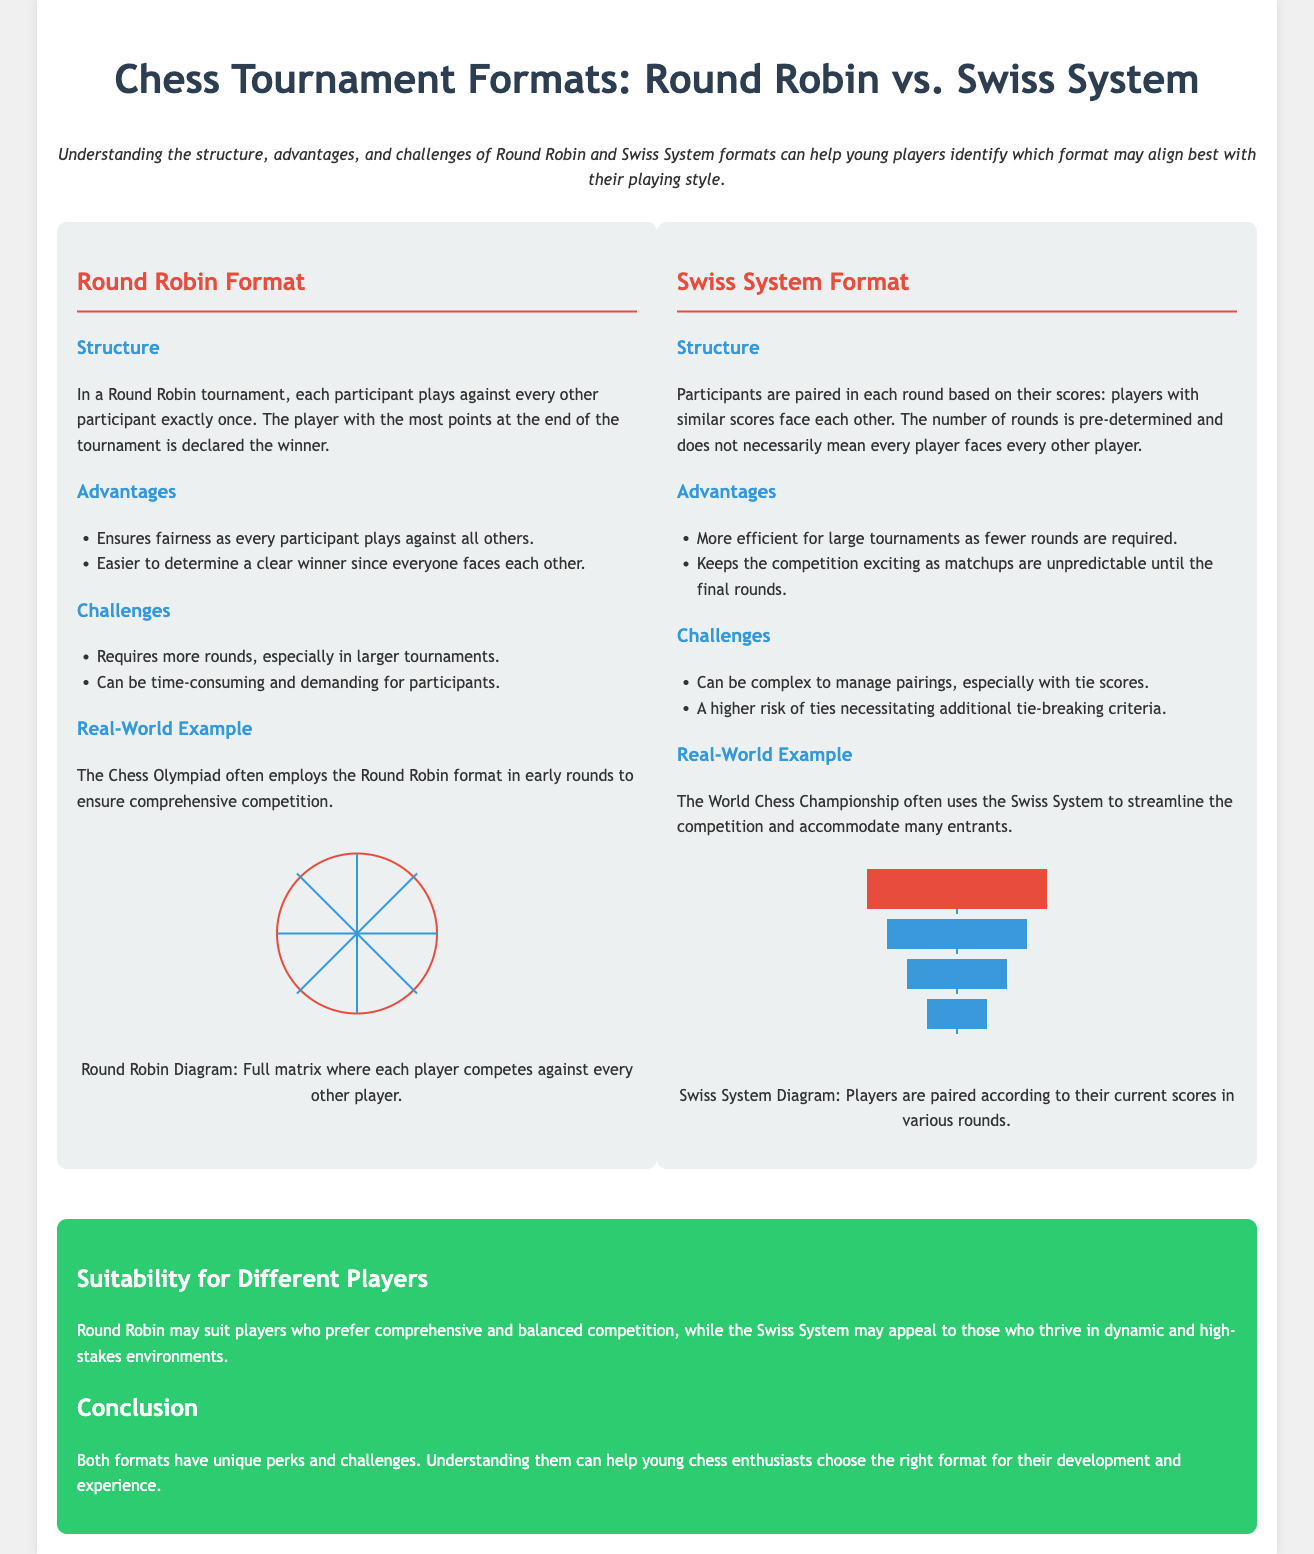What is the title of the document? The title of the document is stated at the top and indicates the focus on chess tournament formats, specifically comparing Round Robin and Swiss System.
Answer: Chess Tournament Formats: Round Robin vs. Swiss System What is one advantage of the Round Robin format? The document lists advantages for the Round Robin format, highlighting fairness as a key benefit.
Answer: Ensures fairness What is a challenge of the Swiss System format? The challenges for the Swiss System format are documented, with complexity in managing pairings being one of them.
Answer: Complex to manage pairings How are players paired in the Swiss System format? The document explains that players are paired based on their scores, emphasizing the difference in pairing methods between formats.
Answer: Based on their scores What is a real-world example of a Round Robin format? The document provides examples of tournaments using the formats, specifying a known chess event for the Round Robin approach.
Answer: The Chess Olympiad Which format might suit players who prefer balanced competition? The conclusion section suggests that players looking for balanced gameplay may find one format more suitable than the other.
Answer: Round Robin What color is used for the headings in the Round Robin section? The document uses specific colors for headings, and the Round Robin section is identified by its distinct heading color.
Answer: Red What does the conclusion indicate about both formats? The conclusion summarizes the uniqueness of each format and their implications for players, giving a broad overview.
Answer: Unique perks and challenges 